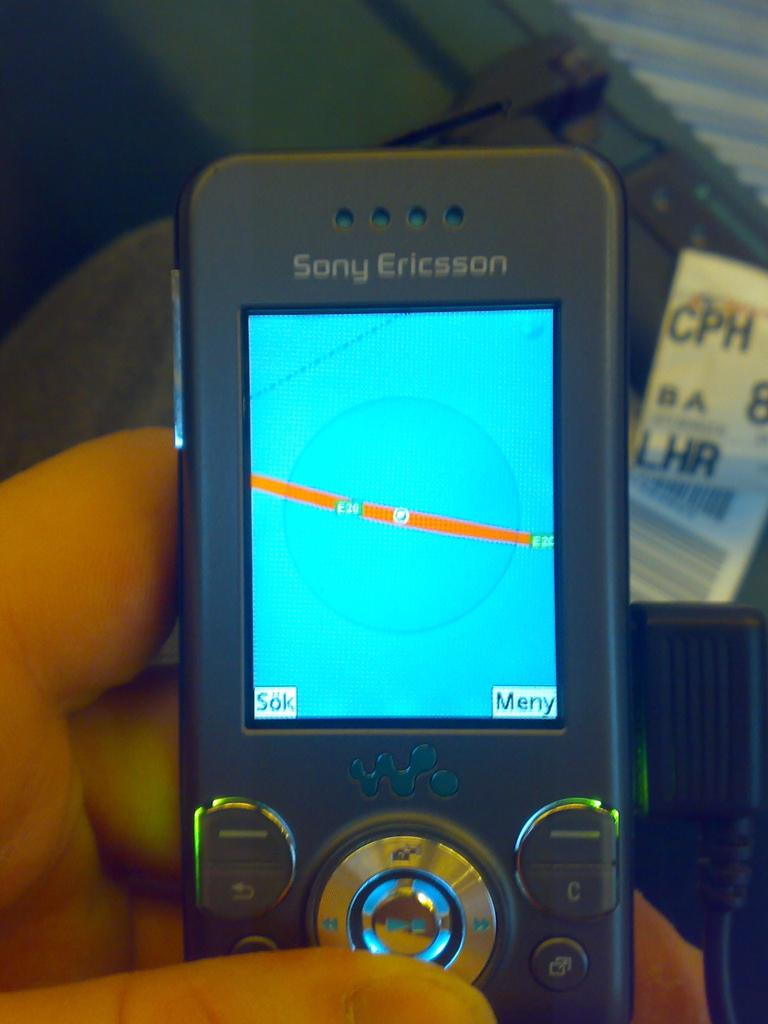<image>
Render a clear and concise summary of the photo. a phone that says sony ericsson at the top 